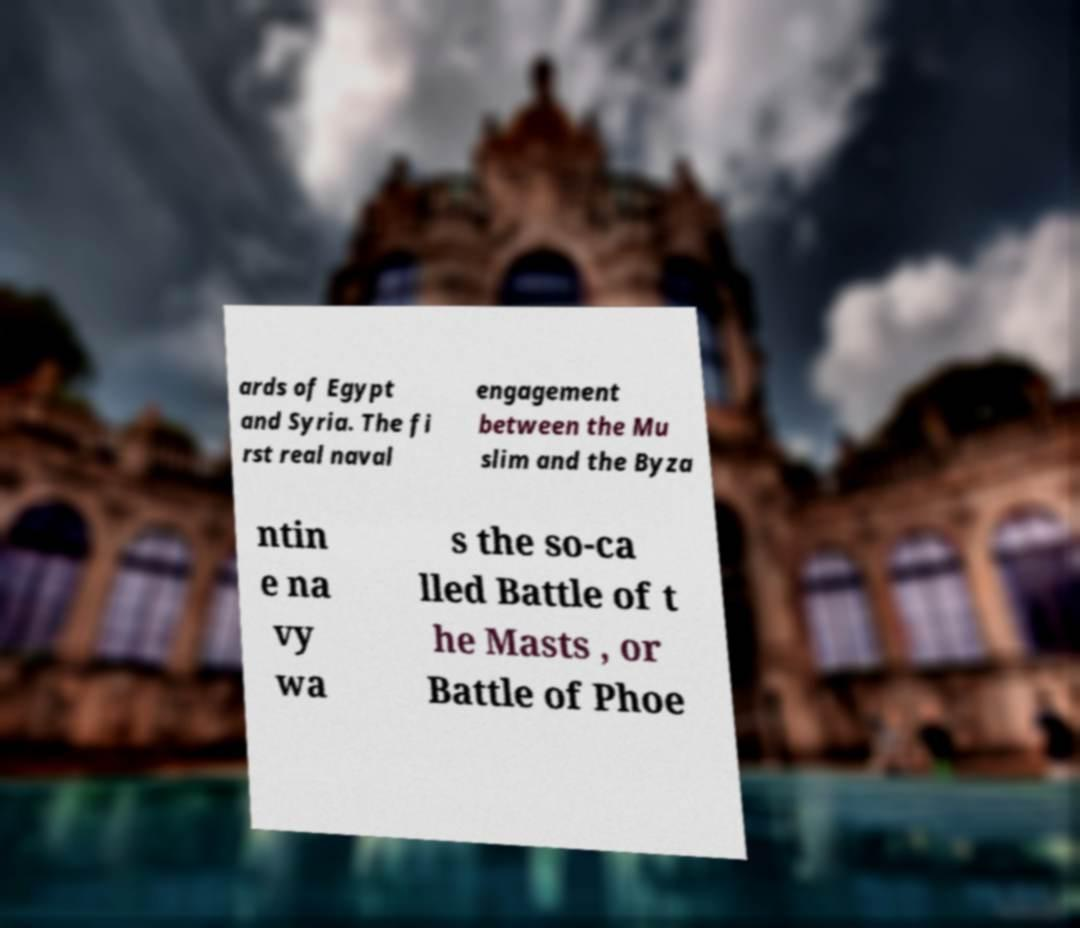Can you accurately transcribe the text from the provided image for me? ards of Egypt and Syria. The fi rst real naval engagement between the Mu slim and the Byza ntin e na vy wa s the so-ca lled Battle of t he Masts , or Battle of Phoe 